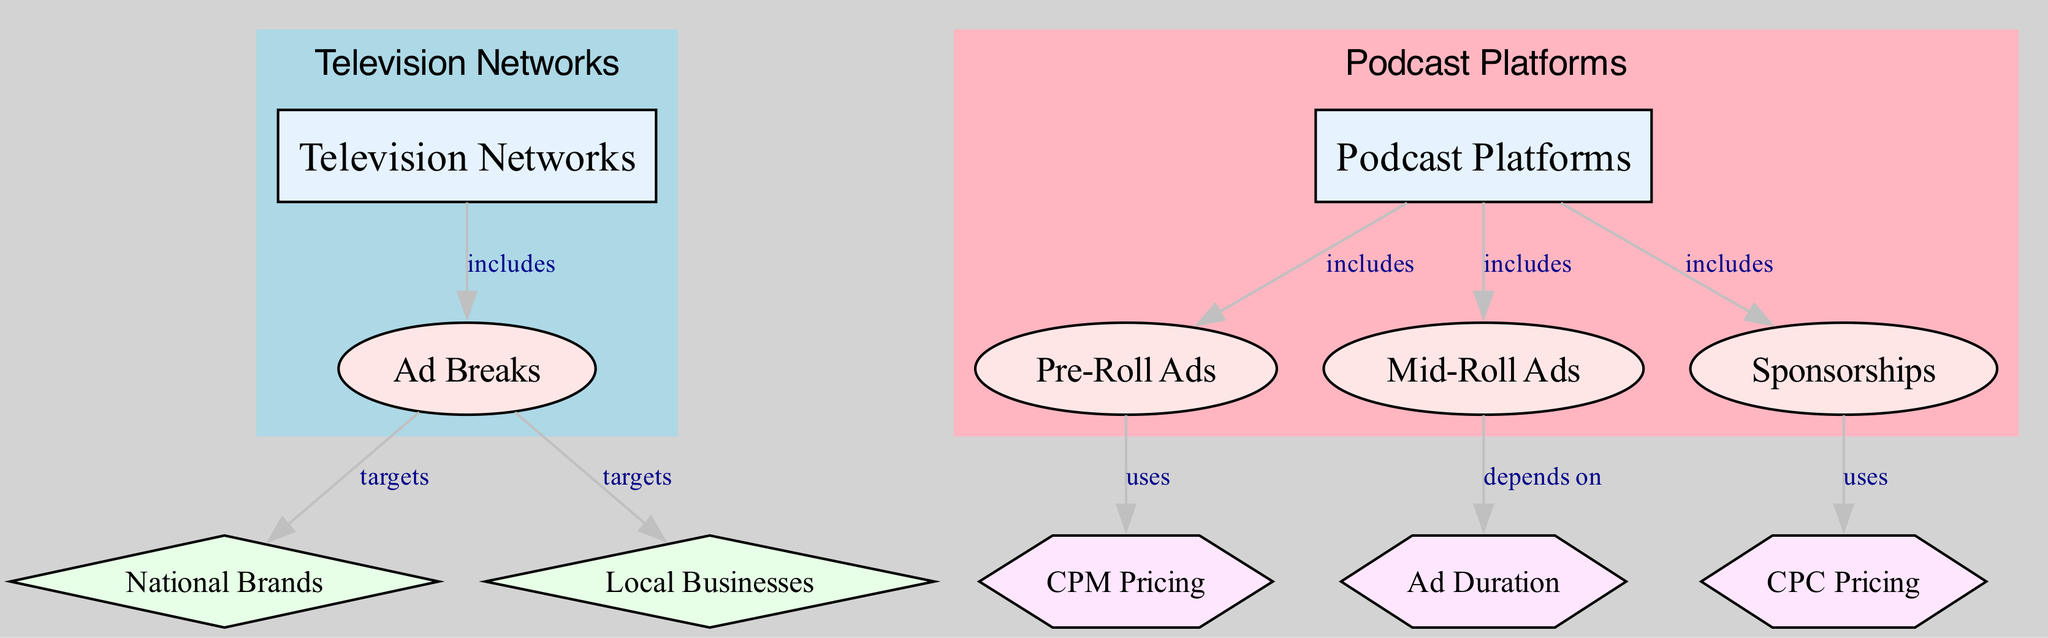What are the two main categories compared in the diagram? The diagram is divided into two main categories: Television Networks and Podcast Platforms. These categories are visually separated and serve as the parent nodes for the respective ad revenue elements.
Answer: Television Networks, Podcast Platforms How many types of ad revenue streams are listed for podcast platforms? Under the category of Podcast Platforms, there are three specific types of ad revenue streams displayed: Pre-Roll Ads, Mid-Roll Ads, and Sponsorships. Thus, counting these three elements gives us the answer.
Answer: 3 Which advertising source targets local businesses? In the diagram, local businesses are targeted specifically by Ad Breaks, indicating that local businesses are a source of advertisement revenue in this context.
Answer: Local Businesses What pricing model is used for pre-roll ads? The diagram indicates that Pre-Roll Ads utilize CPM Pricing, which is specified as a factor directly associated with pre-roll advertising.
Answer: CPM Pricing Which ad type depends on ad duration? The diagram states that Mid-Roll Ads depend on Ad Duration. This means that the effectiveness or configuration of mid-roll ads is influenced by how long the advertisements are.
Answer: Ad Duration What is the relationship between sponsorships and pricing? The diagram illustrates that Sponsorships use CPC Pricing. This tells us there is a direct link showing that the sponsorship ad revenue model applies a cost-per-click pricing strategy.
Answer: CPC Pricing How many edges connect to the podcast platforms category? In examining the edges connecting to the Podcast Platforms category, there are four distinct edges. Each edge corresponds to a different ad type included under the podcast platforms.
Answer: 4 What do national brands specifically target in television networks? National Brands are specifically targeted under the Ad Breaks element, which indicates that during ad breaks on television networks, national brands are looking to reach their audience.
Answer: Ad Breaks Which elements fall under the sponsorships? In the diagram, Sponsorships include the CPC Pricing as a factor, meaning that CPC Pricing is specifically tied to this element of ad revenue.
Answer: CPC Pricing 